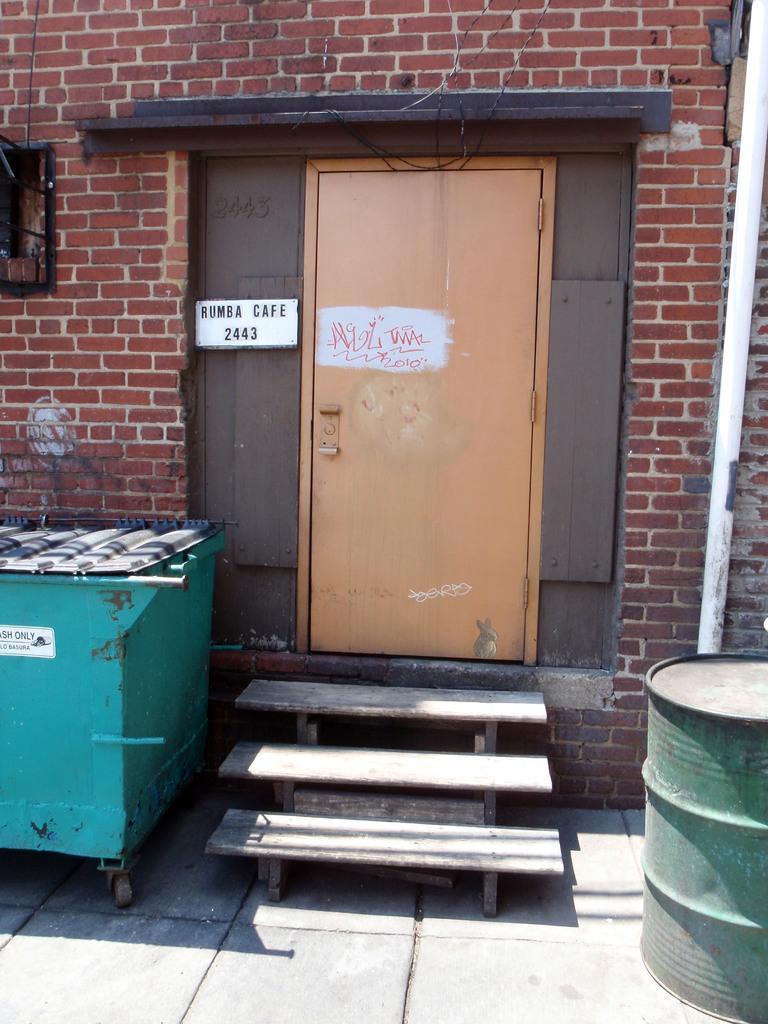In one or two sentences, can you explain what this image depicts? In this image there is a wall having a door. Left side there is an object which is beside the stairs. Right side there is a drum on the floor. 